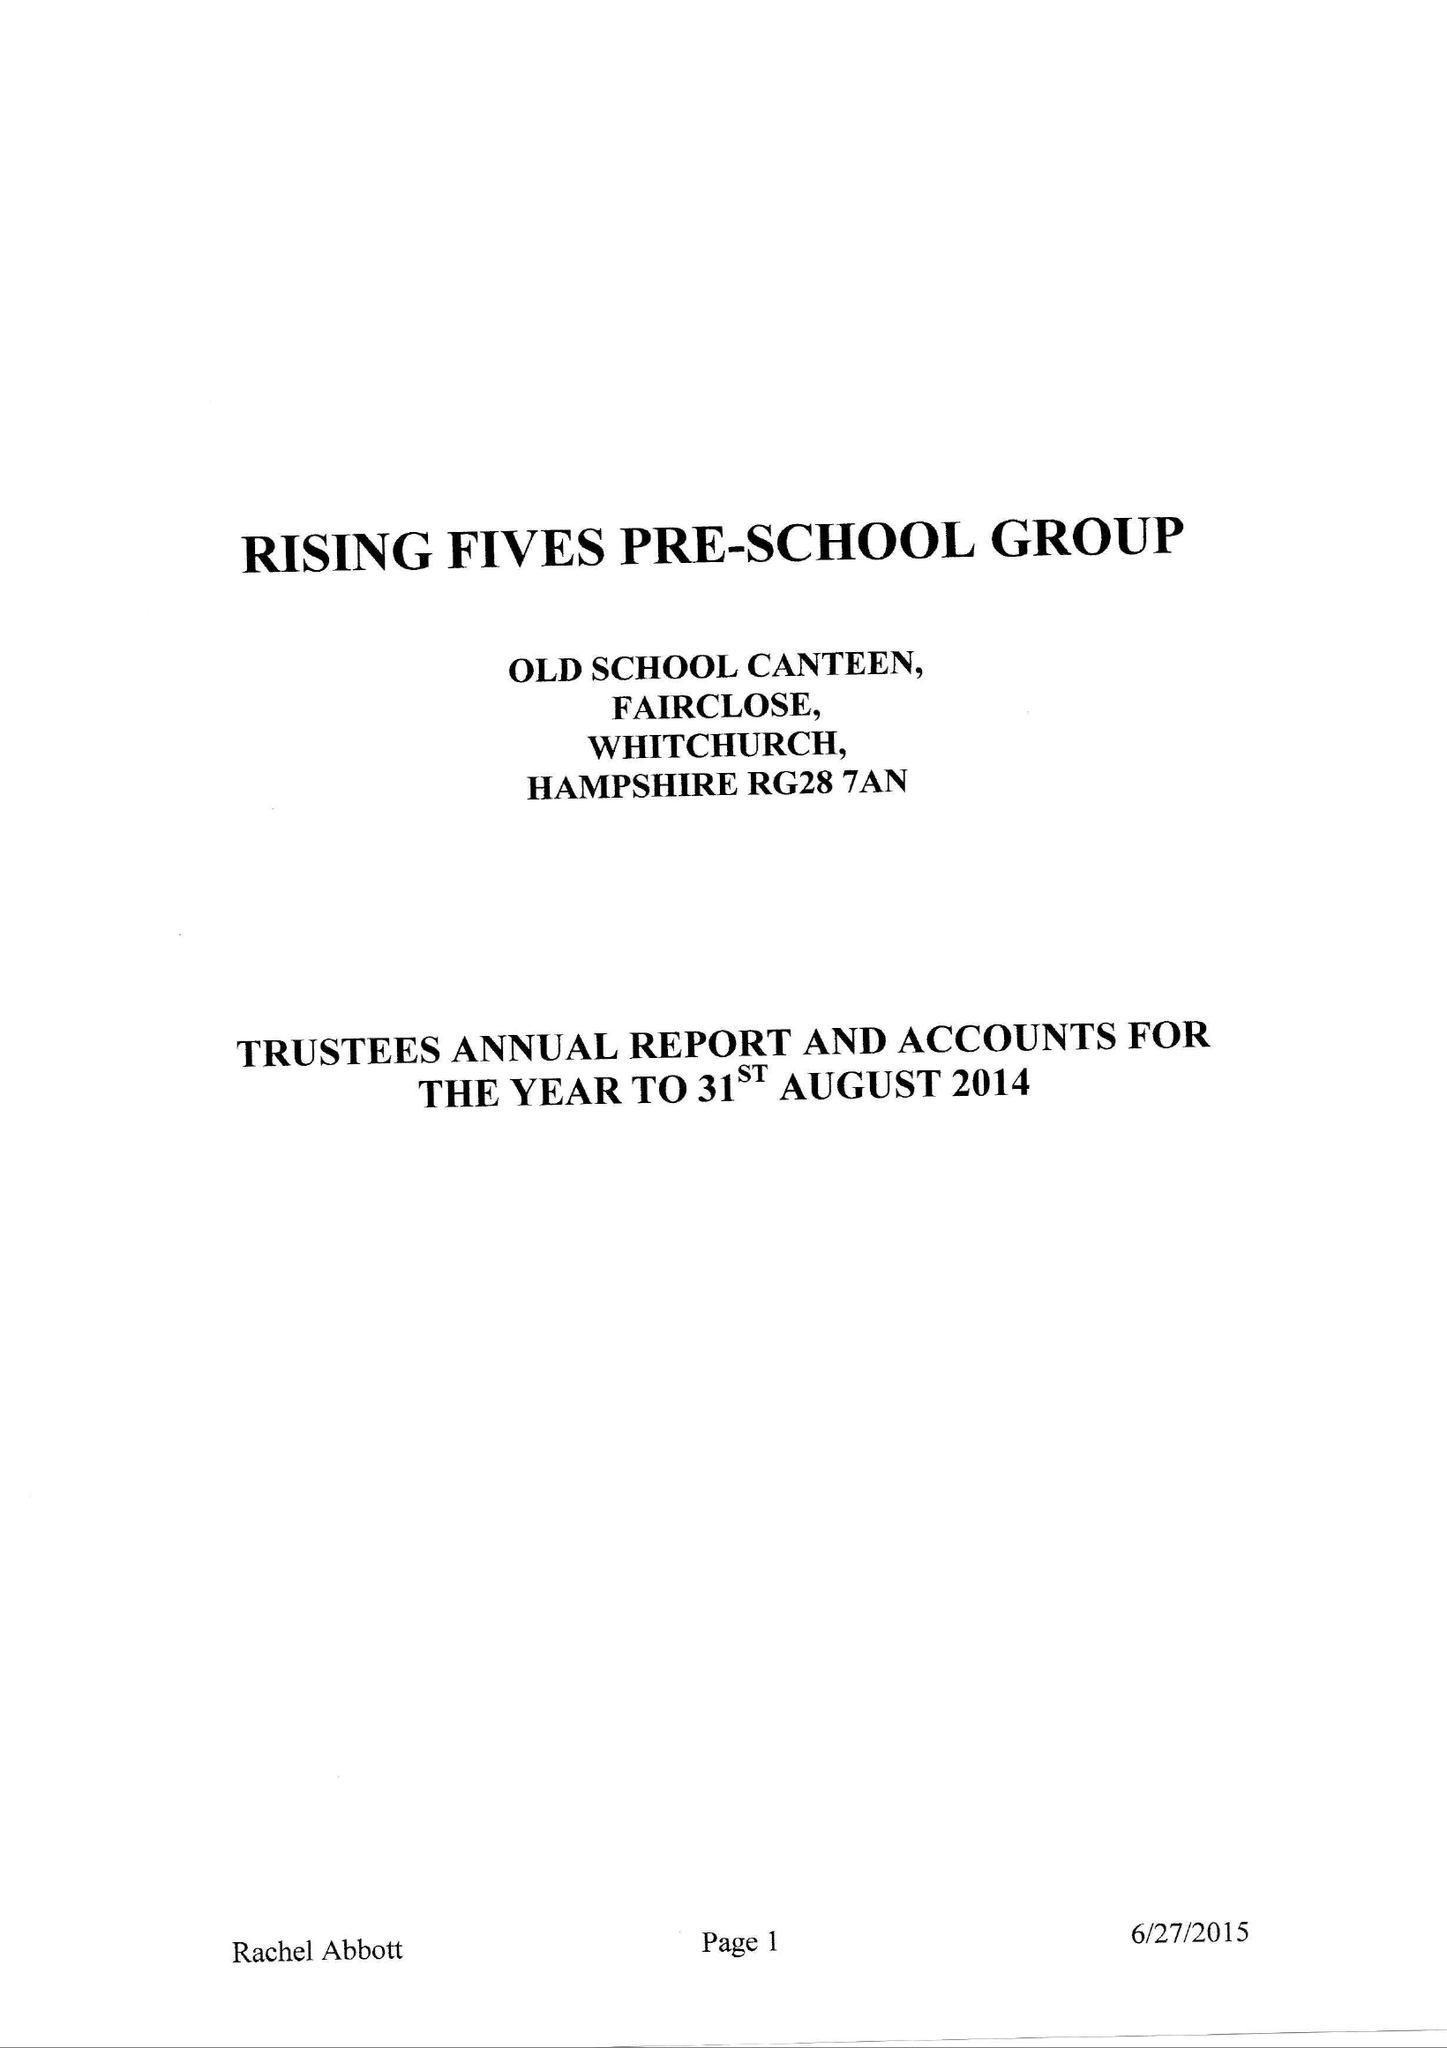What is the value for the address__post_town?
Answer the question using a single word or phrase. WHITCHURCH 